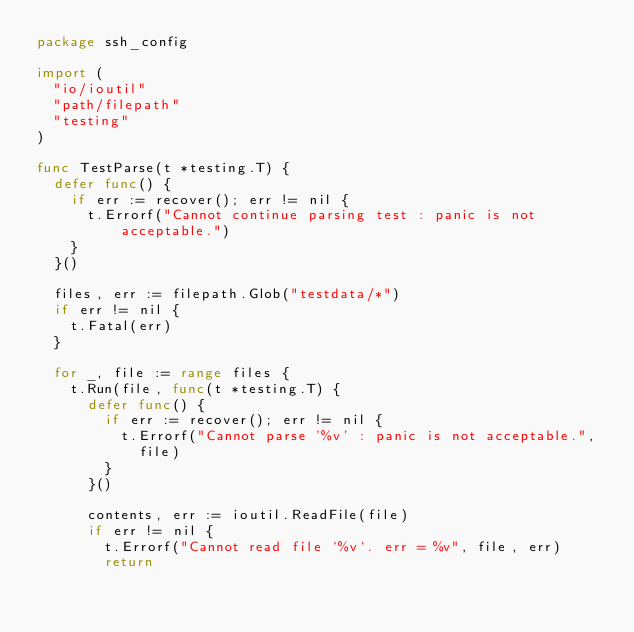<code> <loc_0><loc_0><loc_500><loc_500><_Go_>package ssh_config

import (
	"io/ioutil"
	"path/filepath"
	"testing"
)

func TestParse(t *testing.T) {
	defer func() {
		if err := recover(); err != nil {
			t.Errorf("Cannot continue parsing test : panic is not acceptable.")
		}
	}()

	files, err := filepath.Glob("testdata/*")
	if err != nil {
		t.Fatal(err)
	}

	for _, file := range files {
		t.Run(file, func(t *testing.T) {
			defer func() {
				if err := recover(); err != nil {
					t.Errorf("Cannot parse '%v' : panic is not acceptable.",
						file)
				}
			}()

			contents, err := ioutil.ReadFile(file)
			if err != nil {
				t.Errorf("Cannot read file `%v`. err = %v", file, err)
				return</code> 